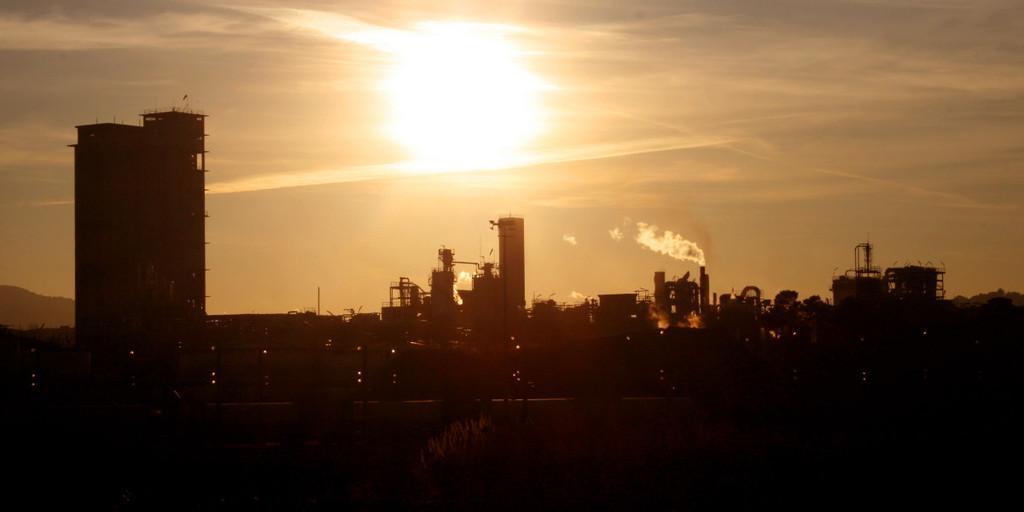How would you summarize this image in a sentence or two? In this image there is the sky towards the top of the image, there is the sun in the sky, there are buildings, there are towers, there is smoke, there is the road, there are plants towards the bottom of the image, there are lights. 